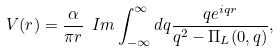Convert formula to latex. <formula><loc_0><loc_0><loc_500><loc_500>V ( r ) = \frac { \alpha } { \pi r } \ I m \int ^ { \infty } _ { - \infty } d q \frac { q e ^ { i q r } } { q ^ { 2 } - \Pi _ { L } ( 0 , q ) } ,</formula> 